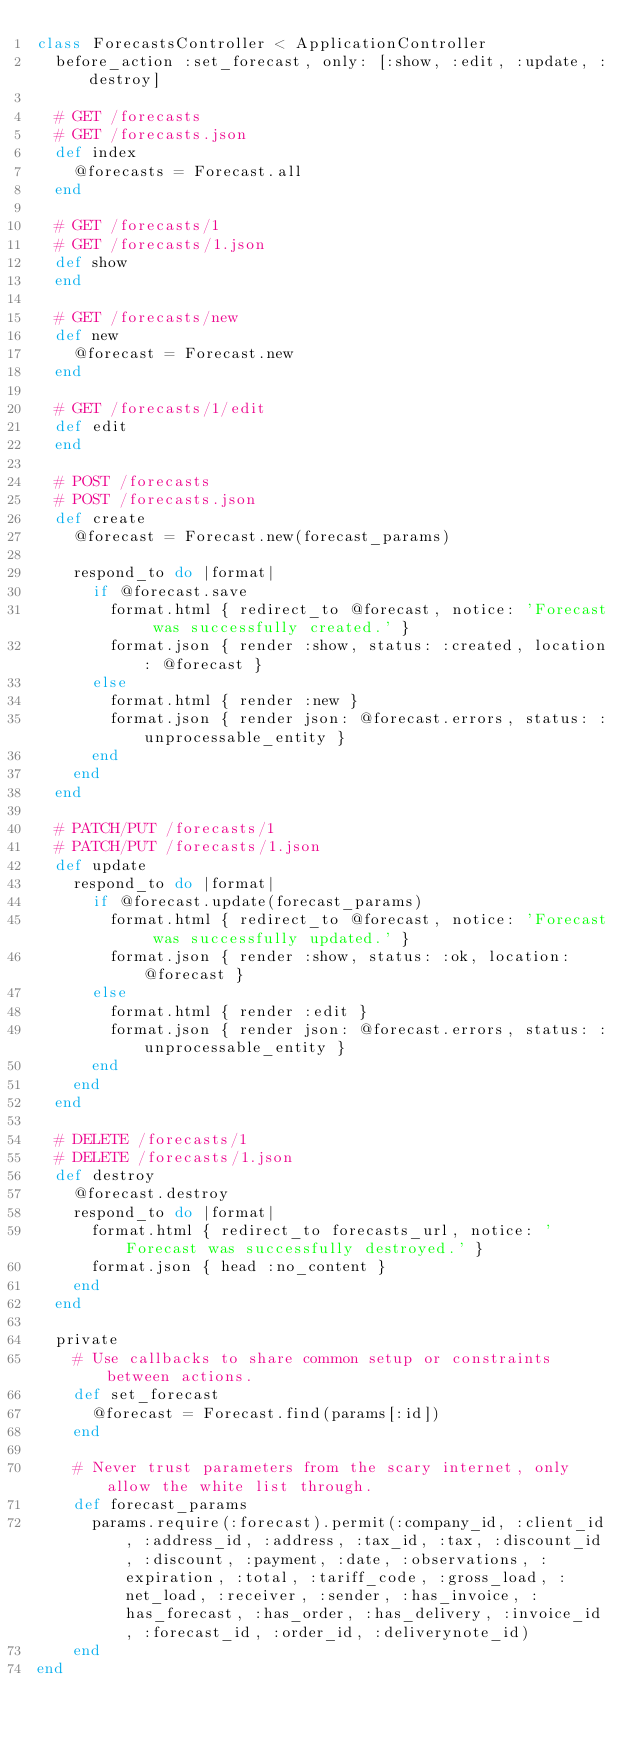Convert code to text. <code><loc_0><loc_0><loc_500><loc_500><_Ruby_>class ForecastsController < ApplicationController
  before_action :set_forecast, only: [:show, :edit, :update, :destroy]

  # GET /forecasts
  # GET /forecasts.json
  def index
    @forecasts = Forecast.all
  end

  # GET /forecasts/1
  # GET /forecasts/1.json
  def show
  end

  # GET /forecasts/new
  def new
    @forecast = Forecast.new
  end

  # GET /forecasts/1/edit
  def edit
  end

  # POST /forecasts
  # POST /forecasts.json
  def create
    @forecast = Forecast.new(forecast_params)

    respond_to do |format|
      if @forecast.save
        format.html { redirect_to @forecast, notice: 'Forecast was successfully created.' }
        format.json { render :show, status: :created, location: @forecast }
      else
        format.html { render :new }
        format.json { render json: @forecast.errors, status: :unprocessable_entity }
      end
    end
  end

  # PATCH/PUT /forecasts/1
  # PATCH/PUT /forecasts/1.json
  def update
    respond_to do |format|
      if @forecast.update(forecast_params)
        format.html { redirect_to @forecast, notice: 'Forecast was successfully updated.' }
        format.json { render :show, status: :ok, location: @forecast }
      else
        format.html { render :edit }
        format.json { render json: @forecast.errors, status: :unprocessable_entity }
      end
    end
  end

  # DELETE /forecasts/1
  # DELETE /forecasts/1.json
  def destroy
    @forecast.destroy
    respond_to do |format|
      format.html { redirect_to forecasts_url, notice: 'Forecast was successfully destroyed.' }
      format.json { head :no_content }
    end
  end

  private
    # Use callbacks to share common setup or constraints between actions.
    def set_forecast
      @forecast = Forecast.find(params[:id])
    end

    # Never trust parameters from the scary internet, only allow the white list through.
    def forecast_params
      params.require(:forecast).permit(:company_id, :client_id, :address_id, :address, :tax_id, :tax, :discount_id, :discount, :payment, :date, :observations, :expiration, :total, :tariff_code, :gross_load, :net_load, :receiver, :sender, :has_invoice, :has_forecast, :has_order, :has_delivery, :invoice_id, :forecast_id, :order_id, :deliverynote_id)
    end
end
</code> 